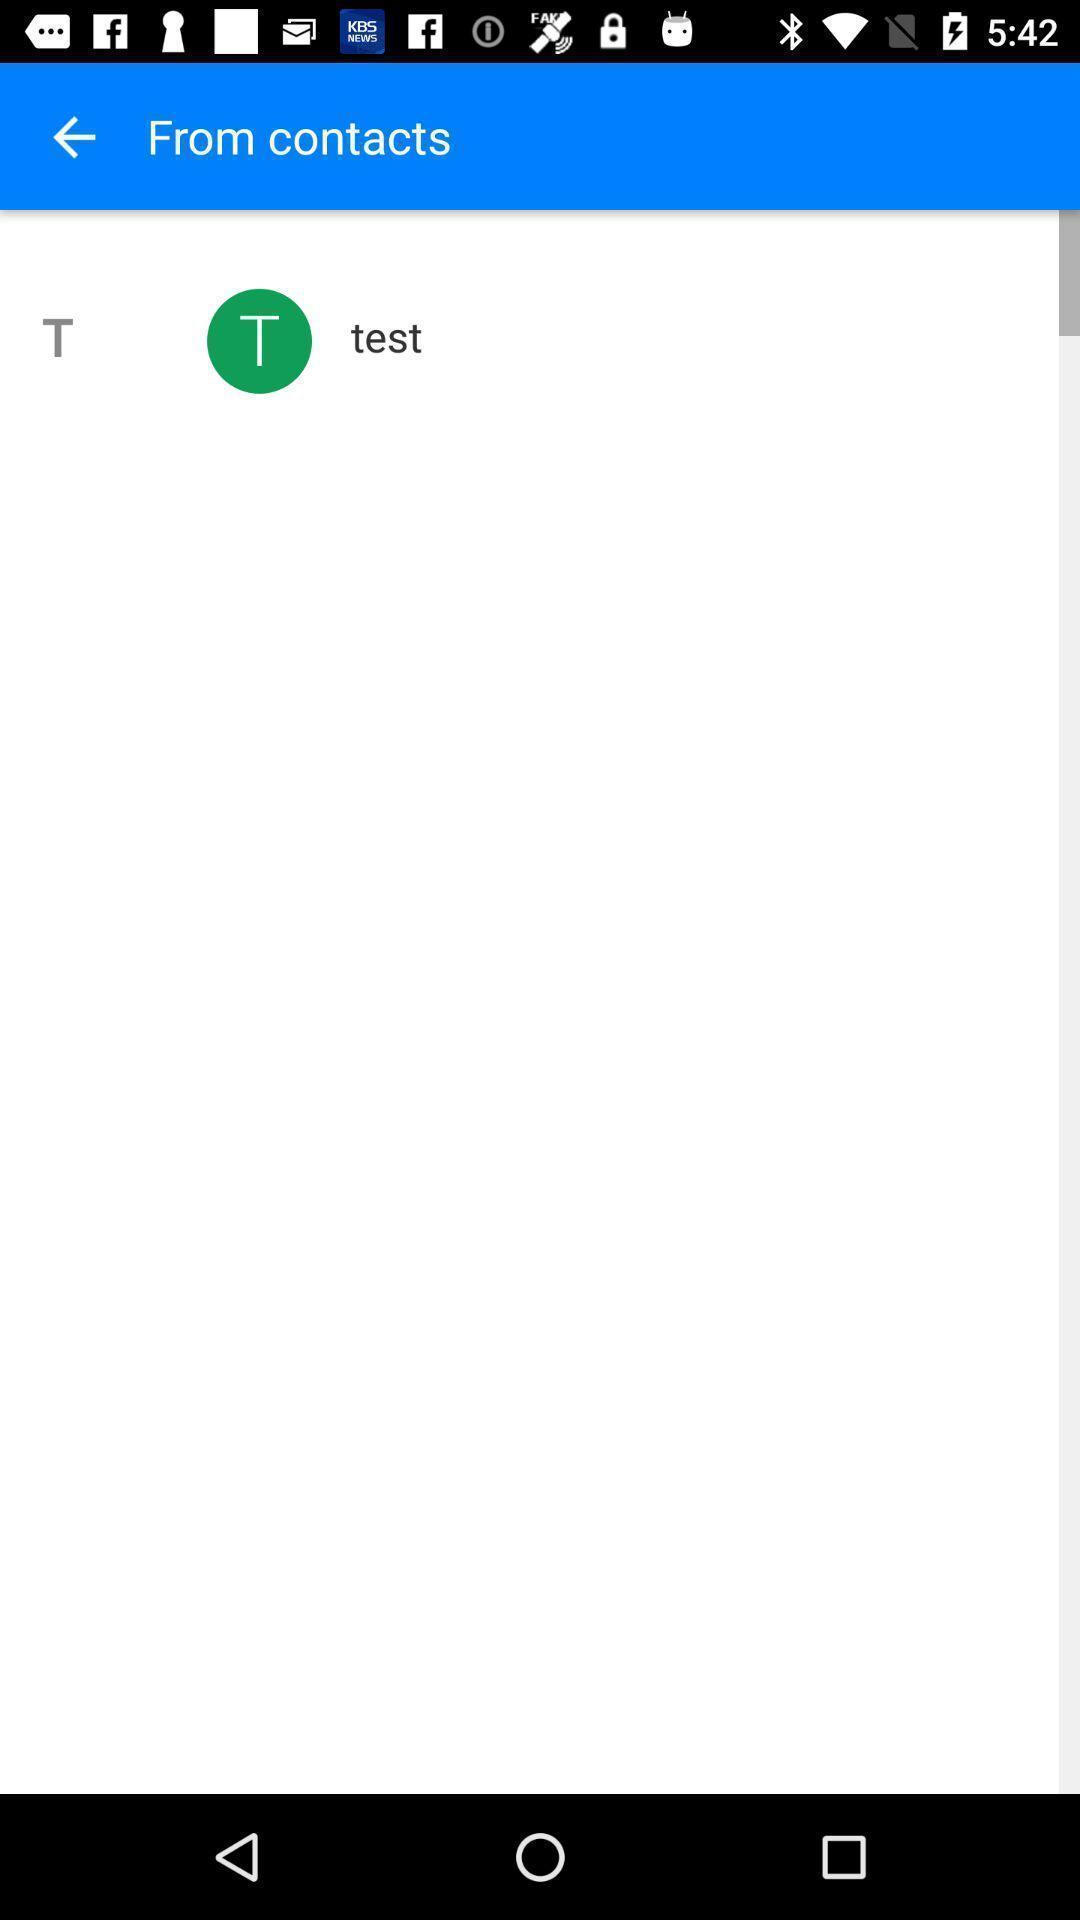Provide a textual representation of this image. Page showing contacts page. 